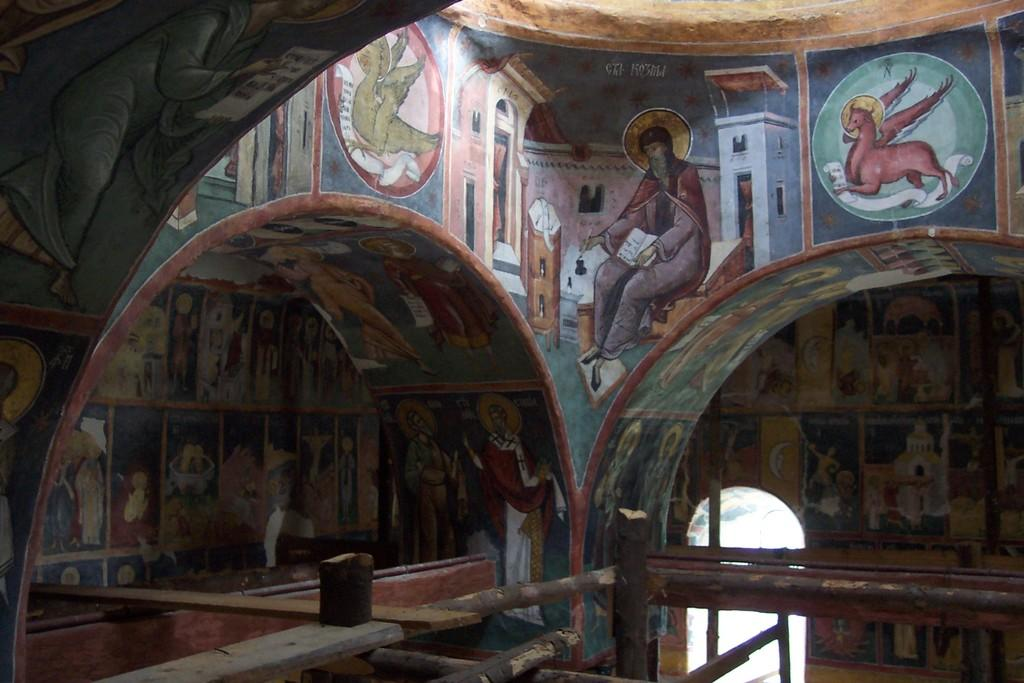Where was the image taken? The image is taken inside a building. What can be seen on the walls in the image? There are paintings on the wall in the image. What architectural feature is present in the image? There is an arch in the image. What objects are visible in the image that resemble long, thin rods? There are sticks visible in the image. Can you see a stream flowing through the building in the image? No, there is no stream visible in the image. What type of fruit is hanging from the arch in the image? There is no fruit, specifically quince, present in the image. 